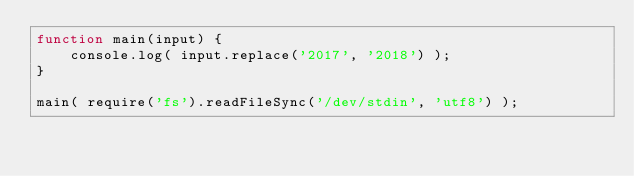Convert code to text. <code><loc_0><loc_0><loc_500><loc_500><_JavaScript_>function main(input) {
    console.log( input.replace('2017', '2018') );
}

main( require('fs').readFileSync('/dev/stdin', 'utf8') );</code> 